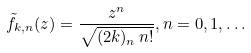<formula> <loc_0><loc_0><loc_500><loc_500>\tilde { f } _ { k , n } ( z ) = \frac { z ^ { n } } { \sqrt { ( 2 k ) _ { n } \, n ! } } , n = 0 , 1 , \dots</formula> 